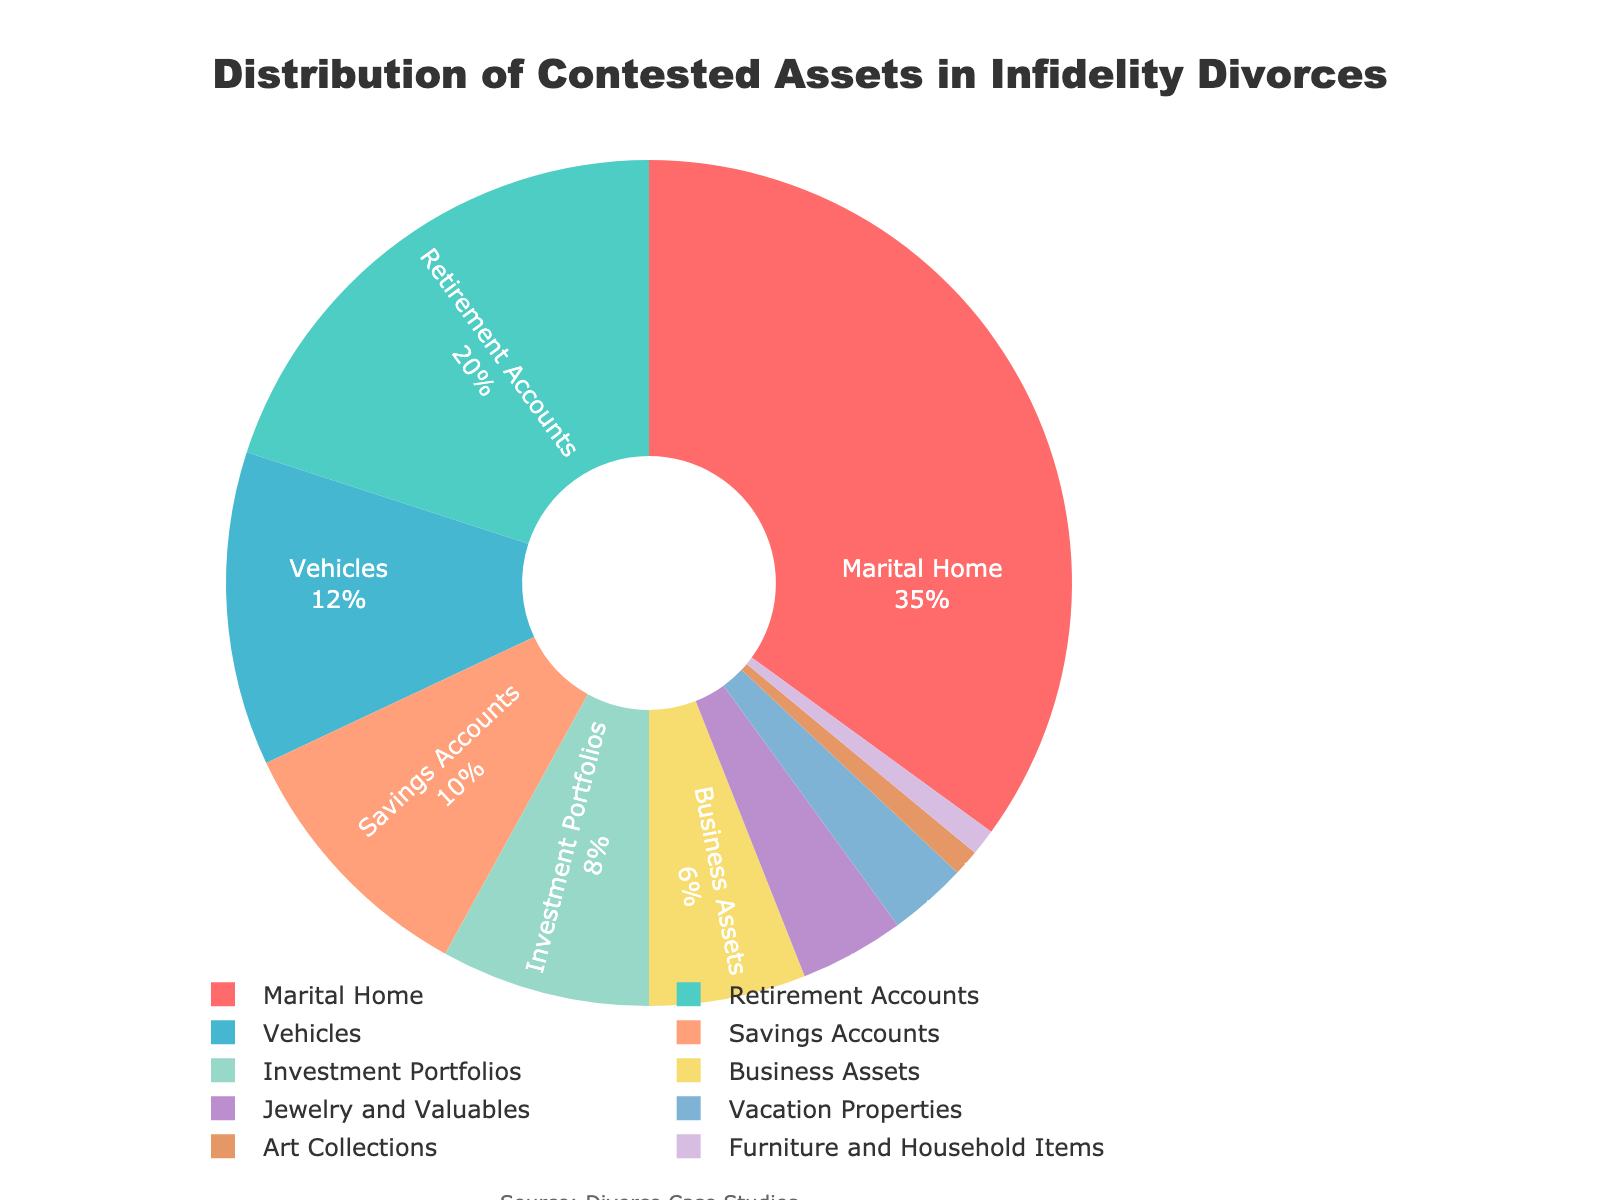What is the asset type with the highest percentage? The segment representing the Marital Home in the pie chart is the largest, indicating it has the highest percentage among all asset types.
Answer: Marital Home Which two asset types combined constitute more than 50% of the contested assets? Adding the percentages of Marital Home (35%) and Retirement Accounts (20%) gives a total of 55%, which is more than 50%.
Answer: Marital Home and Retirement Accounts How much higher is the percentage of contested Vehicles compared to Jewelry and Valuables? The percentage for Vehicles is 12% and for Jewelry and Valuables is 4%. Subtracting these two percentages, 12% - 4% gives 8%.
Answer: 8% Compare the percentage of Business Assets to Savings Accounts. Which one has a higher percentage and by how much? Savings Accounts have a percentage of 10%, while Business Assets have 6%. The difference is 10% - 6% which is 4%. Therefore, Savings Accounts have a higher percentage by 4%.
Answer: Savings Accounts by 4% What is the combined percentage of the least contested assets (each with a percentage of 1%)? Adding the percentages of Art Collections (1%) and Furniture and Household Items (1%) gives a total of 1% + 1%, which is 2%.
Answer: 2% How does the percentage of Investment Portfolios compare to Vehicles? Vehicles have a percentage of 12%, while Investment Portfolios have 8%. Since 12% > 8%, Vehicles have a higher percentage.
Answer: Vehicles have a higher percentage What percentage of the contested assets is due to Vacation Properties? Vacation Properties are displayed with a segment showing a percentage of 3% in the pie chart.
Answer: 3% What is the total percentage of contested assets in the categories with more than 10% each? Marital Home (35%), Retirement Accounts (20%), and Vehicles (12%) each have more than 10%. Adding them gives 35% + 20% + 12% = 67%.
Answer: 67% Which asset types together make up roughly a third of the contested assets? Retirement Accounts (20%) and Vehicles (12%) together constitute 20% + 12% = 32%.
Answer: Retirement Accounts and Vehicles 